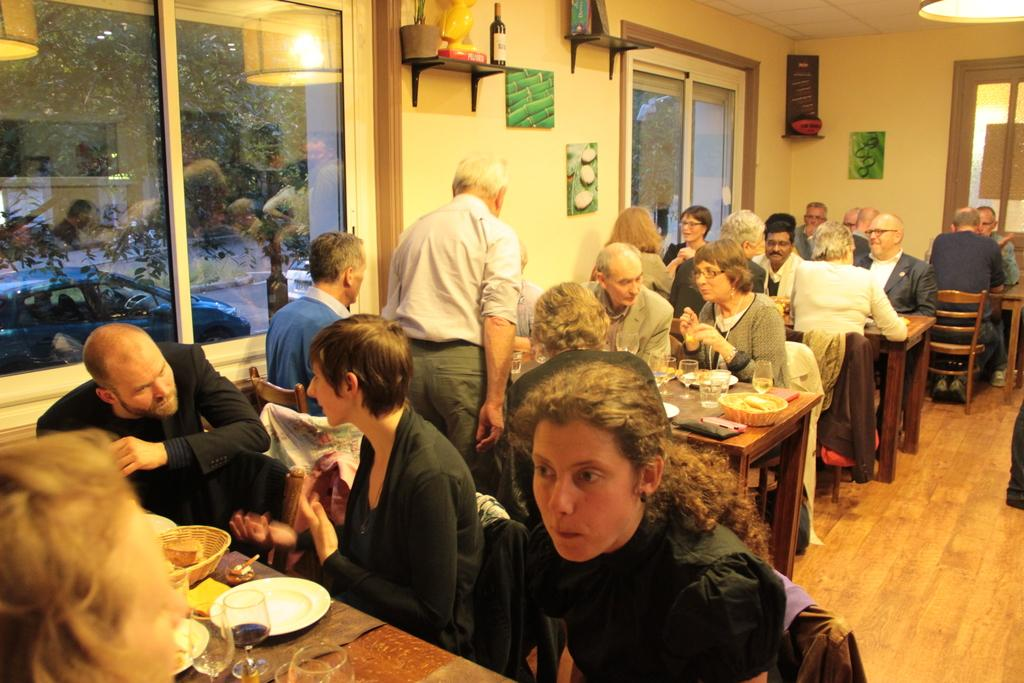How many people are in the image? There is a group of persons in the image. What are the persons doing in the image? The persons are sitting on chairs and having their food. What can be seen on the left side of the image? There is a wall and windows on the left side of the image. Can you see a basketball game happening on the island in the image? There is no island or basketball game present in the image. 